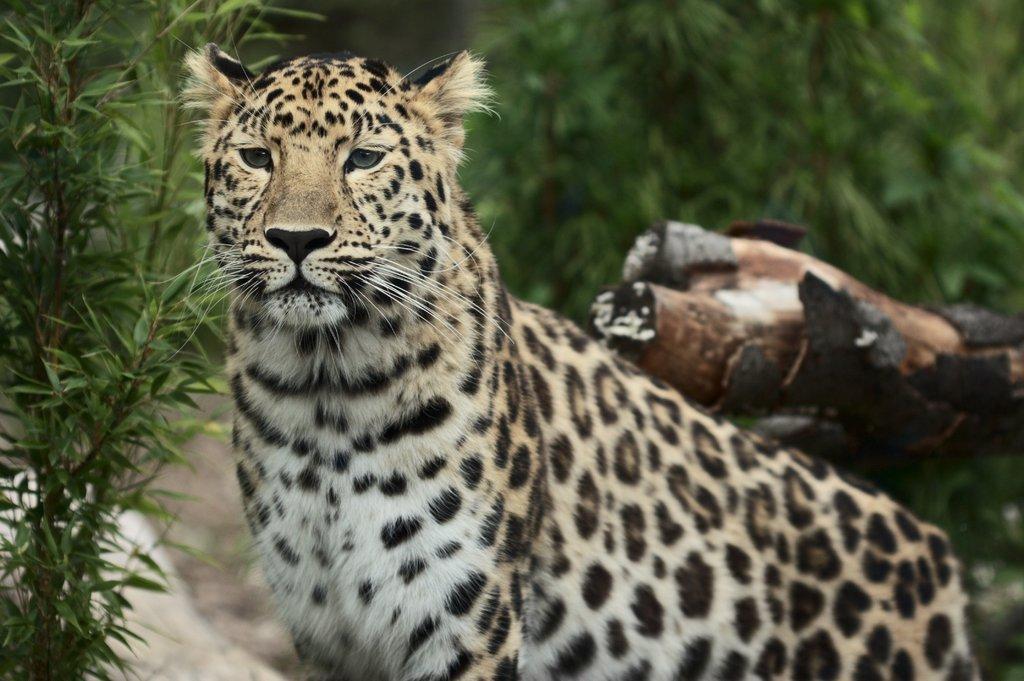Could you give a brief overview of what you see in this image? In the center of the image we can see cheetah. In the background we can see trees and plants. 